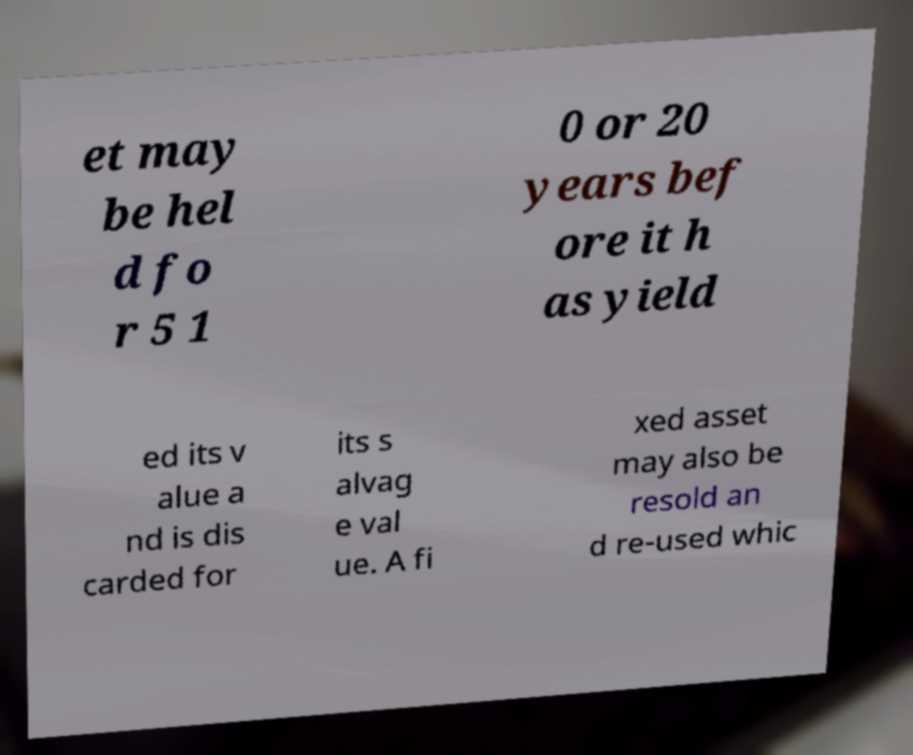For documentation purposes, I need the text within this image transcribed. Could you provide that? et may be hel d fo r 5 1 0 or 20 years bef ore it h as yield ed its v alue a nd is dis carded for its s alvag e val ue. A fi xed asset may also be resold an d re-used whic 